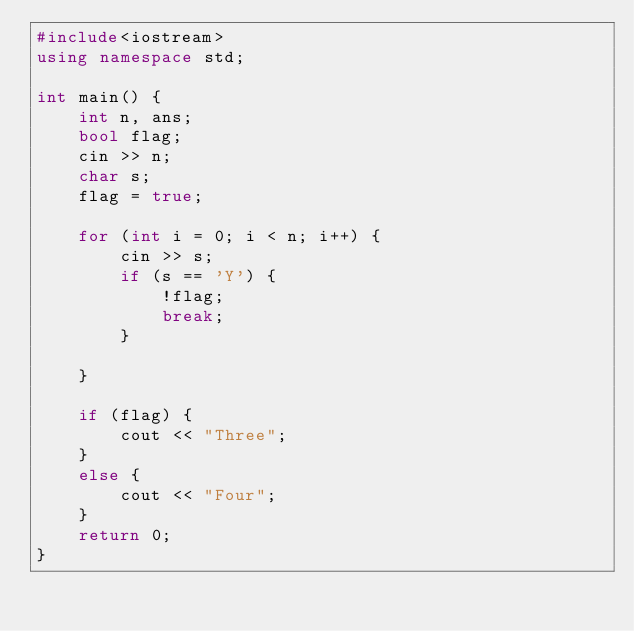<code> <loc_0><loc_0><loc_500><loc_500><_C++_>#include<iostream>
using namespace std;

int main() {
	int n, ans;
	bool flag;
	cin >> n;
	char s;
	flag = true;

	for (int i = 0; i < n; i++) {
		cin >> s;
		if (s == 'Y') {
			!flag;
			break;
		}

	}
	
	if (flag) {
		cout << "Three";
	}
	else {
		cout << "Four";
	}
	return 0;
}</code> 